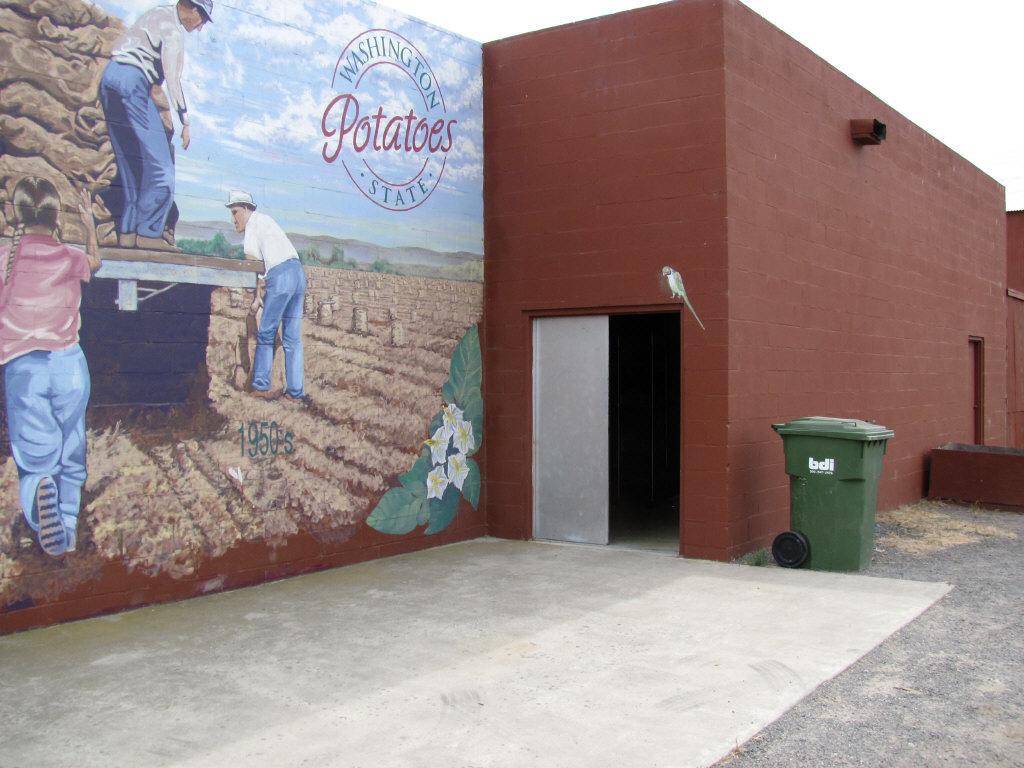What state is on the mural?
Keep it short and to the point. Washington. The mural is beautiful but is that a farm warehouse?
Make the answer very short. Yes. 